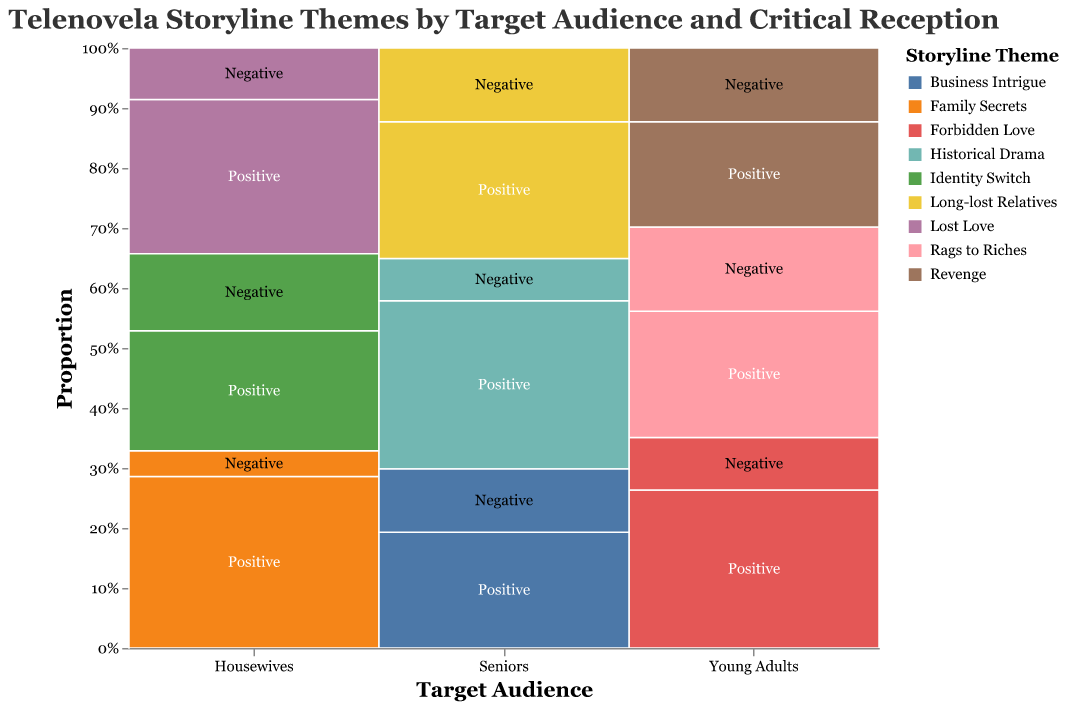What is the title of the plot? The title is the text at the top of the plot. It provides an overview of the key information being visualized. In this case, the title should summarize the data categories and purpose of the plot.
Answer: Telenovela Storyline Themes by Target Audience and Critical Reception How are the storyline themes represented in the plot? The storyline themes are represented by different colors within the mosaic plot to differentiate between various themes visually.
Answer: By different colors Which target audience has the highest positive reception for 'Family Secrets'? To answer this, identify the target audience and the corresponding reception category for 'Family Secrets', and then find the area or section that indicates positive reception within that audience.
Answer: Housewives How many storyline themes are there for the 'Young Adults' target audience? The mosaic plot divides the data by target audience along the x-axis. Within the 'Young Adults' category, count the distinct colors representing different storyline themes.
Answer: Three Does 'Historical Drama' have a higher positive reception among Seniors compared to Young Adults? Look at the segments related to 'Historical Drama' within the Seniors category and check if there is a corresponding segment in the Young Adults category. Compare the proportion of positive receptions (green sections) between these two groups.
Answer: Yes Which storyline theme is the least popular among Housewives in terms of negative critical reception? Within the Housewife's category on the x-axis, identify the theme that has the smallest area designated for negative reception (red sections).
Answer: Family Secrets What is the percentage of negative reception for 'Revenge' in the 'Young Adults' category? Locate the 'Young Adults' category and find the space representing 'Revenge'. Determine the proportion of the negative reception area (red) compared to the whole section for 'Revenge'.
Answer: 41.2% Compare the positive reception of 'Rags to Riches' between 'Young Adults' and 'Housewives'. Which group has a higher count? Identify the 'Rags to Riches' segments in both target audiences. Compare the height of the green segment (positive reception) in both categories. From the data, compute the counts directly.
Answer: Young Adults What proportion of storyline themes for the 'Seniors' category have positive reception? In the 'Seniors' category, add up the lengths of all green segments and divide by the total length of all segments within this category to get the proportion.
Answer: Majority 